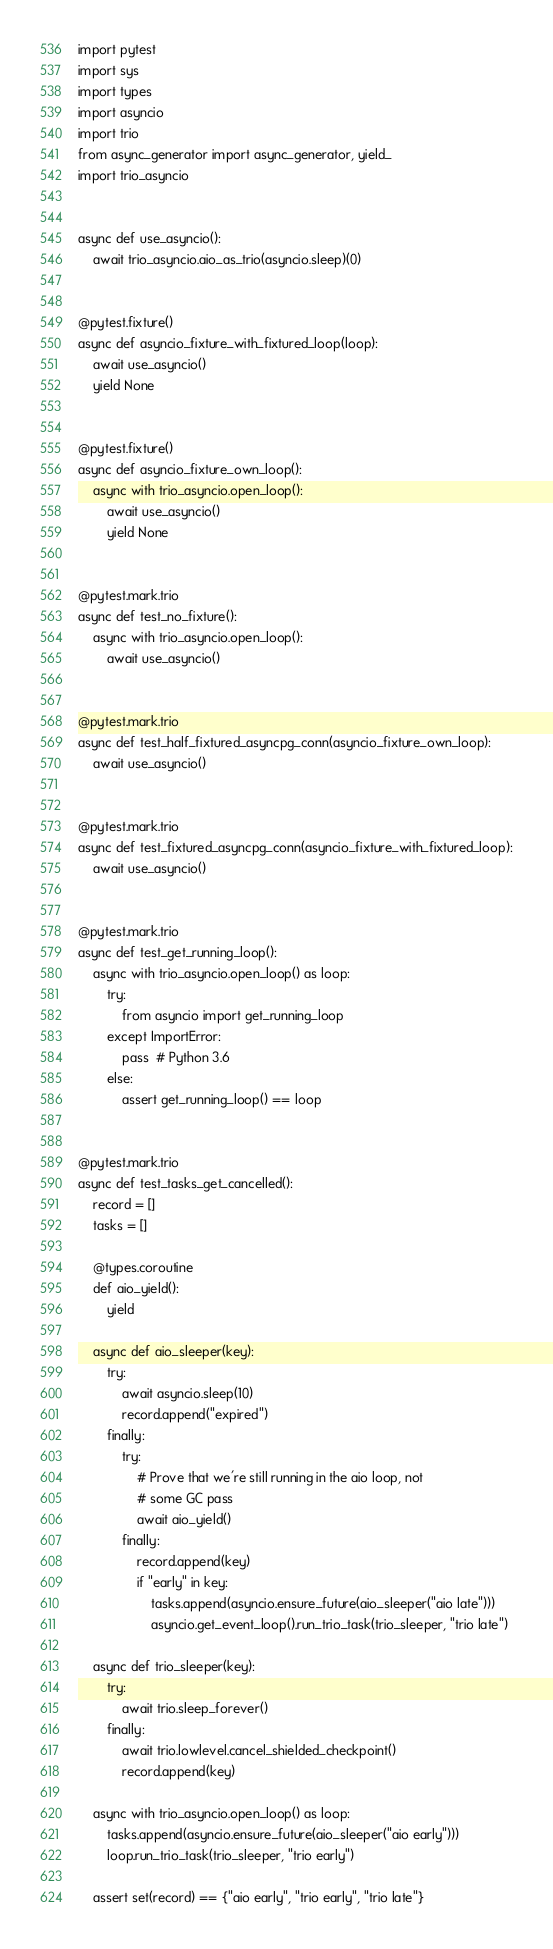<code> <loc_0><loc_0><loc_500><loc_500><_Python_>import pytest
import sys
import types
import asyncio
import trio
from async_generator import async_generator, yield_
import trio_asyncio


async def use_asyncio():
    await trio_asyncio.aio_as_trio(asyncio.sleep)(0)


@pytest.fixture()
async def asyncio_fixture_with_fixtured_loop(loop):
    await use_asyncio()
    yield None


@pytest.fixture()
async def asyncio_fixture_own_loop():
    async with trio_asyncio.open_loop():
        await use_asyncio()
        yield None


@pytest.mark.trio
async def test_no_fixture():
    async with trio_asyncio.open_loop():
        await use_asyncio()


@pytest.mark.trio
async def test_half_fixtured_asyncpg_conn(asyncio_fixture_own_loop):
    await use_asyncio()


@pytest.mark.trio
async def test_fixtured_asyncpg_conn(asyncio_fixture_with_fixtured_loop):
    await use_asyncio()


@pytest.mark.trio
async def test_get_running_loop():
    async with trio_asyncio.open_loop() as loop:
        try:
            from asyncio import get_running_loop
        except ImportError:
            pass  # Python 3.6
        else:
            assert get_running_loop() == loop


@pytest.mark.trio
async def test_tasks_get_cancelled():
    record = []
    tasks = []

    @types.coroutine
    def aio_yield():
        yield

    async def aio_sleeper(key):
        try:
            await asyncio.sleep(10)
            record.append("expired")
        finally:
            try:
                # Prove that we're still running in the aio loop, not
                # some GC pass
                await aio_yield()
            finally:
                record.append(key)
                if "early" in key:
                    tasks.append(asyncio.ensure_future(aio_sleeper("aio late")))
                    asyncio.get_event_loop().run_trio_task(trio_sleeper, "trio late")

    async def trio_sleeper(key):
        try:
            await trio.sleep_forever()
        finally:
            await trio.lowlevel.cancel_shielded_checkpoint()
            record.append(key)

    async with trio_asyncio.open_loop() as loop:
        tasks.append(asyncio.ensure_future(aio_sleeper("aio early")))
        loop.run_trio_task(trio_sleeper, "trio early")

    assert set(record) == {"aio early", "trio early", "trio late"}</code> 